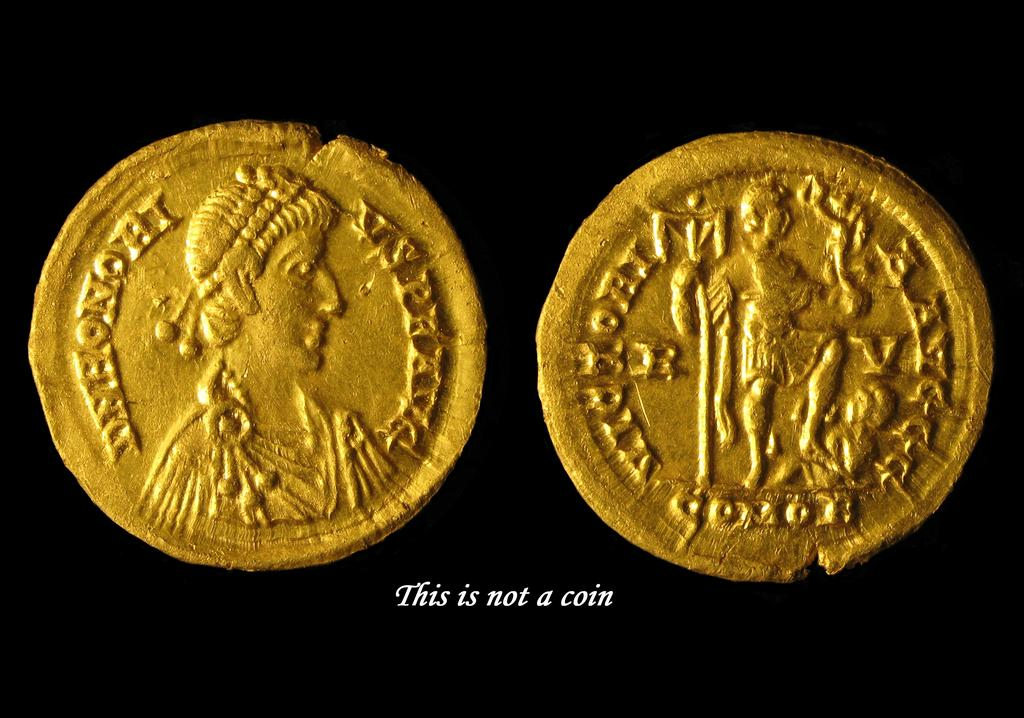<image>
Create a compact narrative representing the image presented. Gold artifact that is labeled it is not a coin 